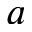Convert formula to latex. <formula><loc_0><loc_0><loc_500><loc_500>a</formula> 